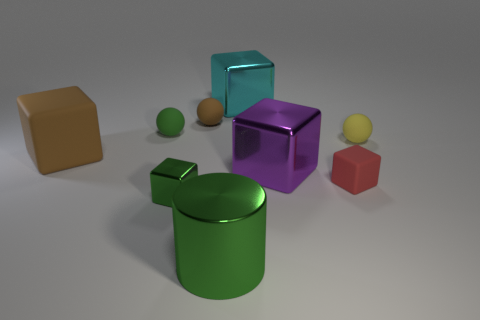What number of things are either red spheres or large green metallic objects?
Offer a very short reply. 1. What material is the green thing behind the object that is to the right of the small red cube that is in front of the brown sphere?
Keep it short and to the point. Rubber. There is a big block left of the shiny cylinder; what material is it?
Offer a very short reply. Rubber. Is there another thing of the same size as the cyan thing?
Your answer should be compact. Yes. Does the tiny rubber sphere that is to the left of the brown sphere have the same color as the metal cylinder?
Your response must be concise. Yes. What number of blue objects are either metallic cylinders or big matte cubes?
Your answer should be compact. 0. How many matte spheres are the same color as the big cylinder?
Give a very brief answer. 1. Are the big brown object and the purple cube made of the same material?
Your response must be concise. No. What number of yellow rubber things are in front of the metallic cube that is in front of the tiny red block?
Keep it short and to the point. 0. Do the green matte sphere and the purple metal thing have the same size?
Provide a short and direct response. No. 